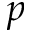<formula> <loc_0><loc_0><loc_500><loc_500>p</formula> 